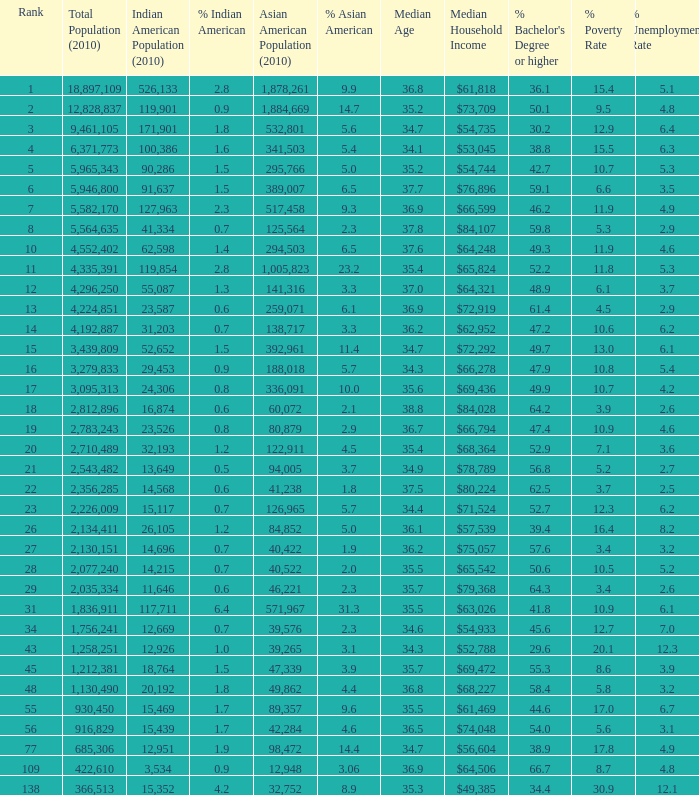What's the total population when there are 5.7% Asian American and fewer than 126,965 Asian American Population? None. 